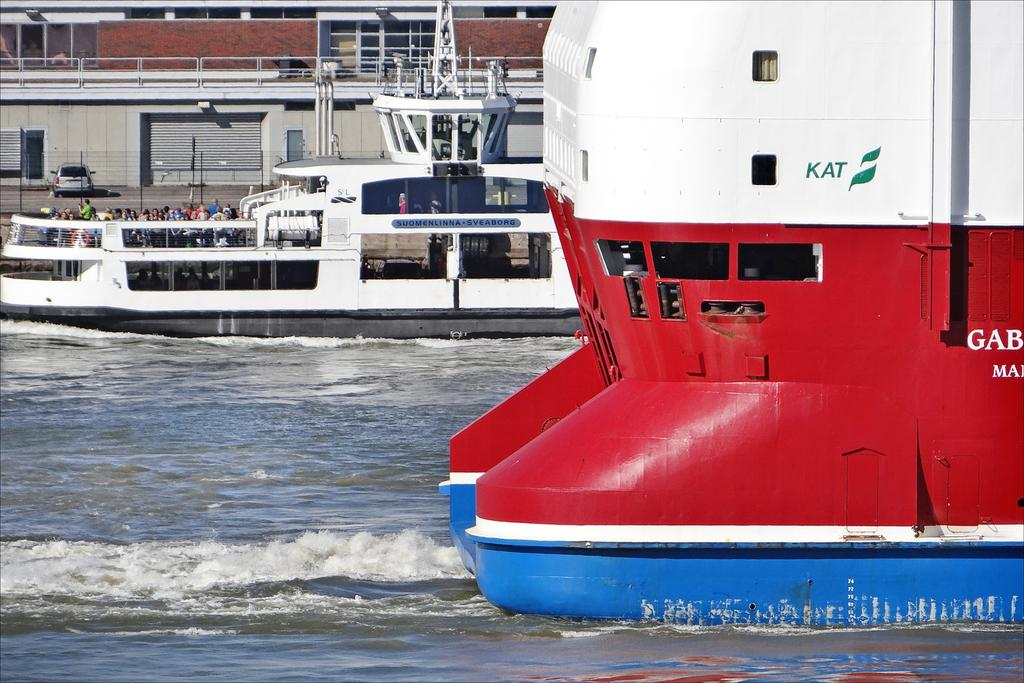<image>
Describe the image concisely. A red, white, and blue boat that says Kat on the back is floating past another boat. 